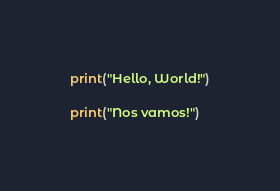<code> <loc_0><loc_0><loc_500><loc_500><_Python_>print("Hello, World!")

print("Nos vamos!")
</code> 